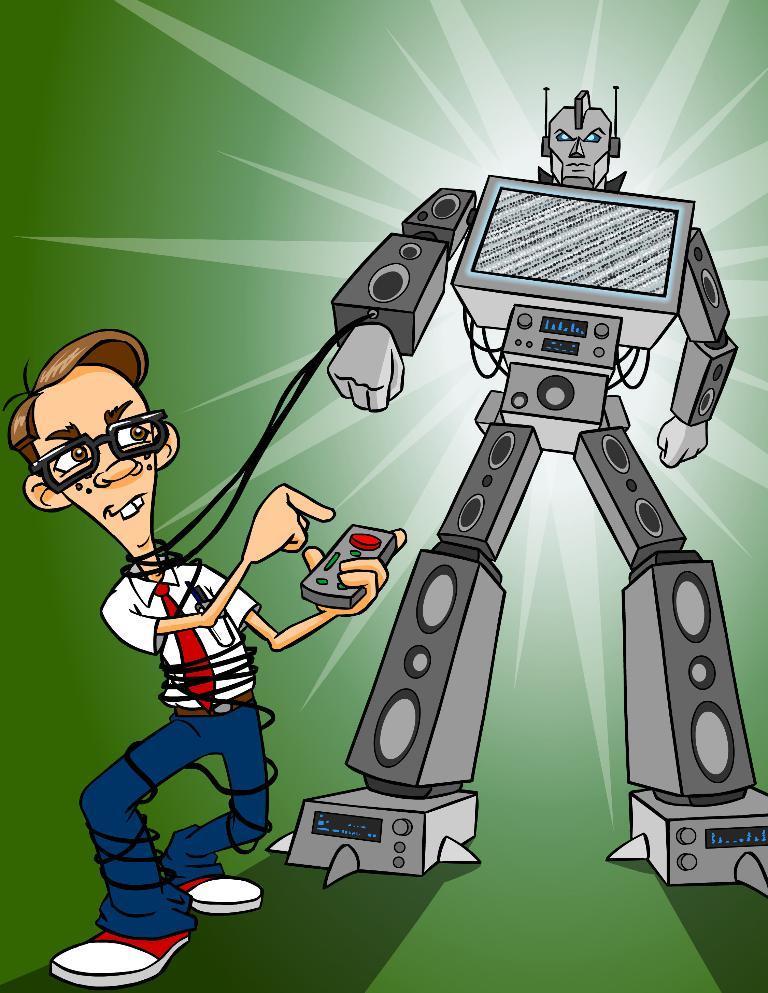Can you describe this image briefly? In the picture I can see an animated robot on the right side and there is another animated image of a boy on the left side holding a remote. 